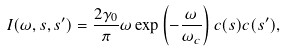<formula> <loc_0><loc_0><loc_500><loc_500>I ( \omega , s , s ^ { \prime } ) = \frac { 2 \gamma _ { 0 } } { \pi } \omega \exp \left ( - \frac { \omega } { \omega _ { c } } \right ) c ( s ) c ( s ^ { \prime } ) ,</formula> 